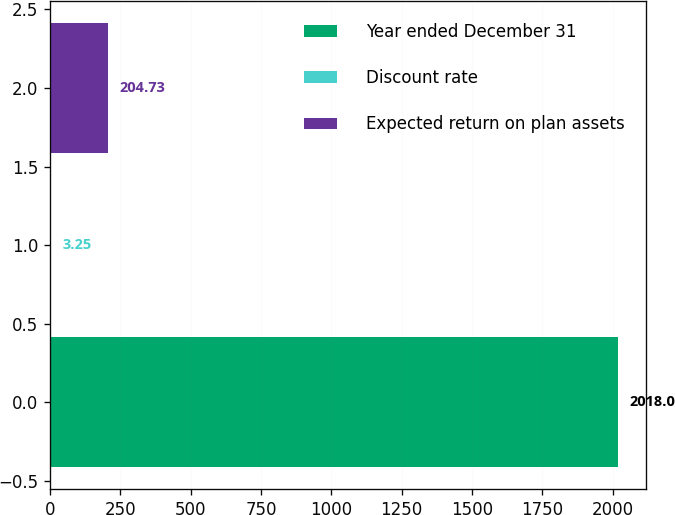Convert chart to OTSL. <chart><loc_0><loc_0><loc_500><loc_500><bar_chart><fcel>Year ended December 31<fcel>Discount rate<fcel>Expected return on plan assets<nl><fcel>2018<fcel>3.25<fcel>204.73<nl></chart> 